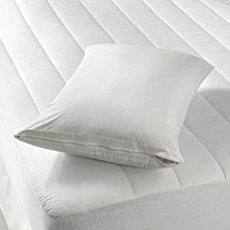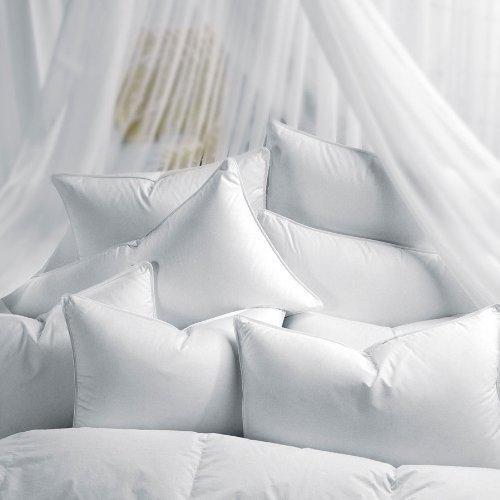The first image is the image on the left, the second image is the image on the right. Considering the images on both sides, is "One of the images contains exactly two white pillows." valid? Answer yes or no. No. 